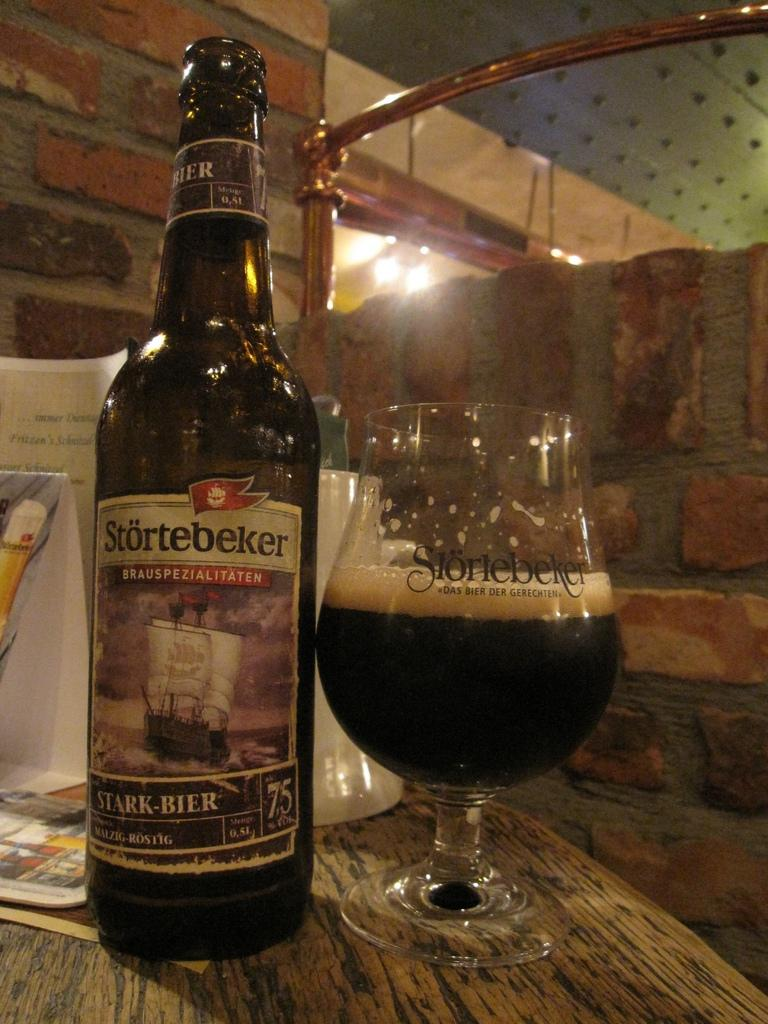<image>
Give a short and clear explanation of the subsequent image. The word Brauspezialitaten is on the beer bottle 